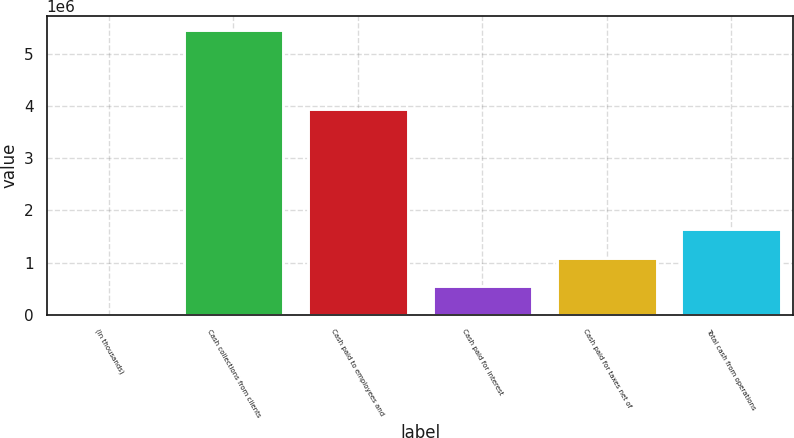Convert chart to OTSL. <chart><loc_0><loc_0><loc_500><loc_500><bar_chart><fcel>(In thousands)<fcel>Cash collections from clients<fcel>Cash paid to employees and<fcel>Cash paid for interest<fcel>Cash paid for taxes net of<fcel>Total cash from operations<nl><fcel>2017<fcel>5.44453e+06<fcel>3.9324e+06<fcel>546268<fcel>1.09052e+06<fcel>1.63477e+06<nl></chart> 